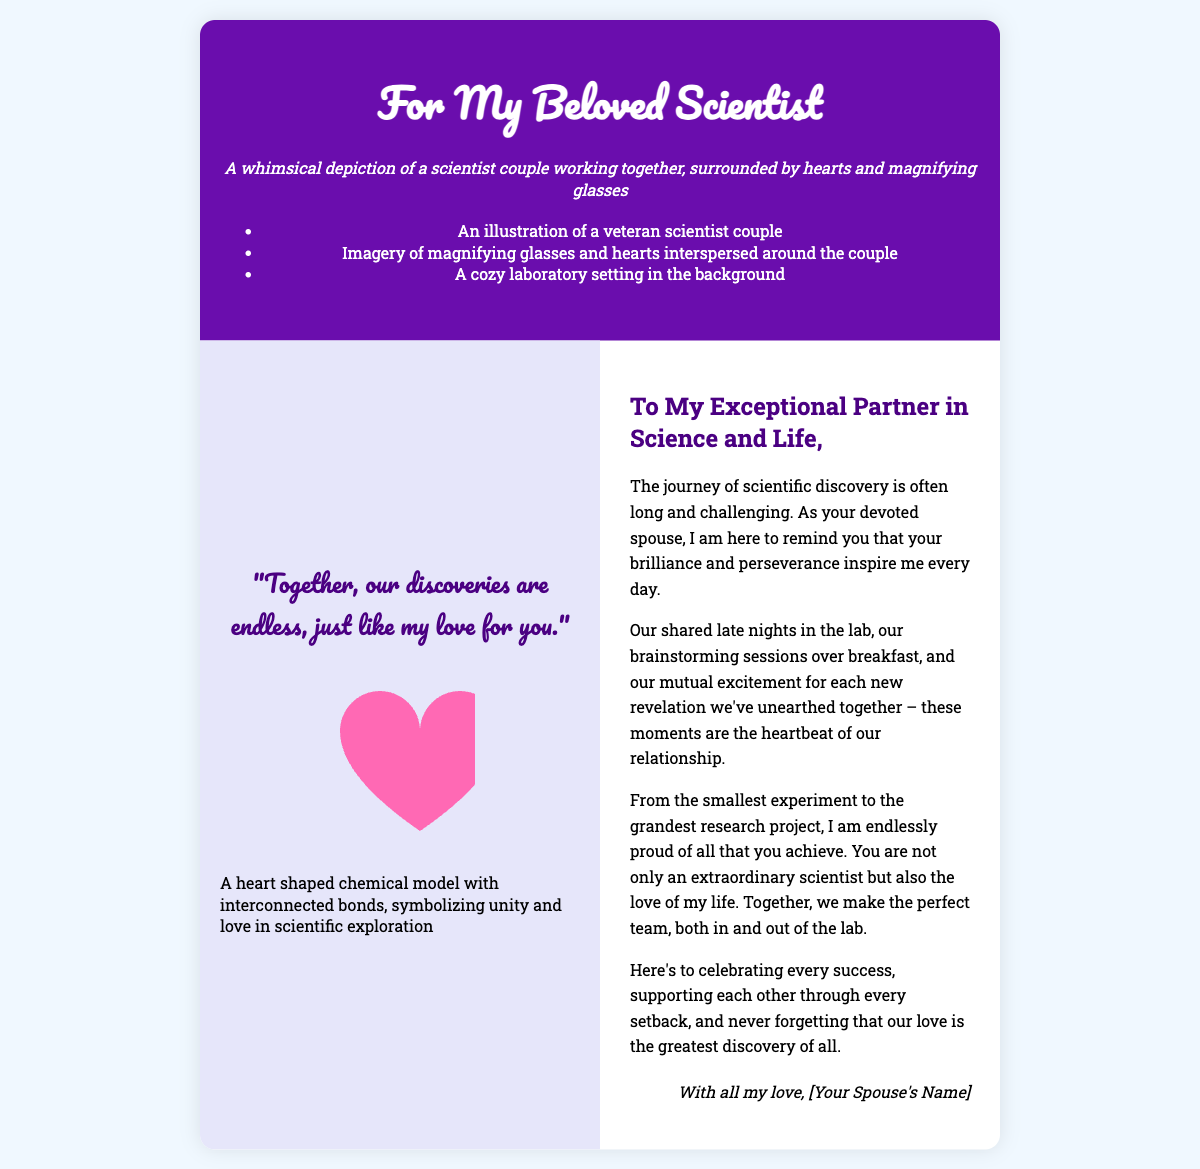What is the title of the card? The title is written prominently on the front cover of the card.
Answer: For My Beloved Scientist What colors dominate the front cover? The front cover features a dark color scheme contrasting with white text.
Answer: Purple and white How many sections are there inside the card? The card has clearly defined sections that allow for structured messages.
Answer: Two sections What is the quote on the inside left? The quote reflects the sentiment of partnership and encouragement in scientific endeavors.
Answer: "Together, our discoveries are endless, just like my love for you." What shape does the heart model represent? The heart model visually represents emotions connected to scientific collaboration and love.
Answer: Heart Who is the card addressed to? The greeting specifically recognizes and appreciates the recipient’s contributions.
Answer: My Exceptional Partner in Science and Life What is depicted in the background of the front cover? The image reflects a setting that would be familiar to those in the scientific community.
Answer: A cozy laboratory setting What does the heart model symbolize? The heart model serves as a metaphorical expression bridging science and affection.
Answer: Unity and love in scientific exploration 